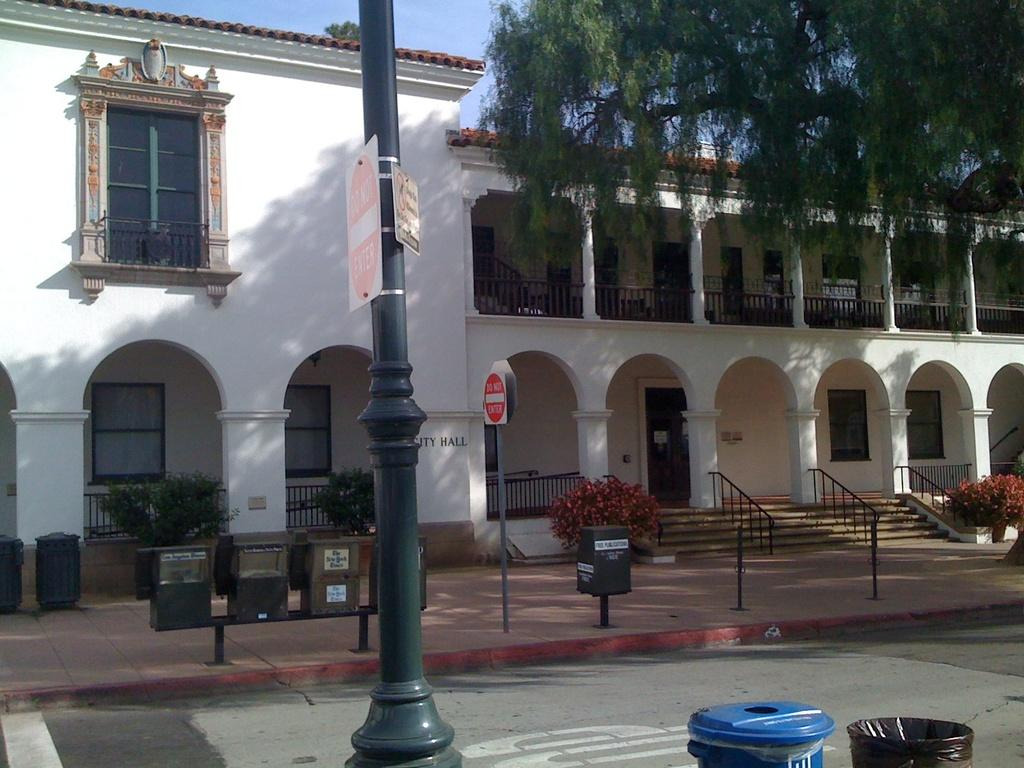What type of surface can be seen in the image? There is a road in the image. What natural element is present in the image? There is a tree in the image. What type of vegetation is visible in the image? There are plants in the image. What objects are present for waste disposal? Dustbins are present in the image. What objects provide information or directions? Signboards are visible in the image. What type of vertical structures are present in the image? Poles are present in the image. What objects provide safety or guidance? Railings are visible in the image. What type of structure is visible in the image? There is a building with windows in the image. What part of the natural environment is visible in the background of the image? The sky is visible in the background of the image. What type of appliance is being used to apply glue to the health chart in the image? There is no appliance, glue, or health chart present in the image. 